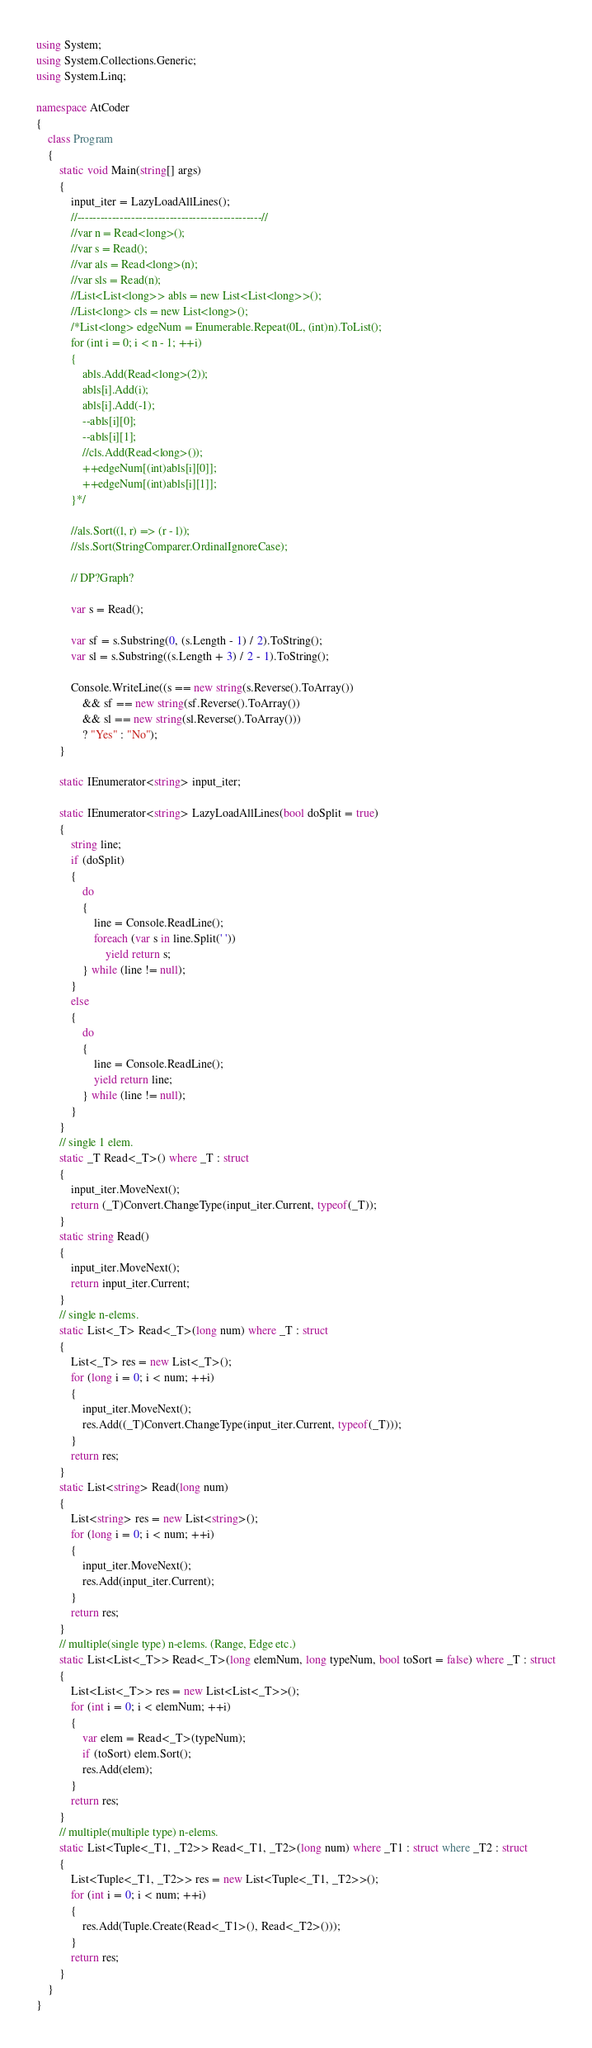Convert code to text. <code><loc_0><loc_0><loc_500><loc_500><_C#_>using System;
using System.Collections.Generic;
using System.Linq;

namespace AtCoder
{
    class Program
    {
        static void Main(string[] args)
        {
            input_iter = LazyLoadAllLines();
            //------------------------------------------------//
            //var n = Read<long>();
            //var s = Read();
            //var als = Read<long>(n);
            //var sls = Read(n);
            //List<List<long>> abls = new List<List<long>>();
            //List<long> cls = new List<long>();
            /*List<long> edgeNum = Enumerable.Repeat(0L, (int)n).ToList();
            for (int i = 0; i < n - 1; ++i)
            {
                abls.Add(Read<long>(2));
                abls[i].Add(i);
                abls[i].Add(-1);
                --abls[i][0];
                --abls[i][1];
                //cls.Add(Read<long>());
                ++edgeNum[(int)abls[i][0]];
                ++edgeNum[(int)abls[i][1]];
            }*/

            //als.Sort((l, r) => (r - l));
            //sls.Sort(StringComparer.OrdinalIgnoreCase);

            // DP?Graph?

            var s = Read();

            var sf = s.Substring(0, (s.Length - 1) / 2).ToString();
            var sl = s.Substring((s.Length + 3) / 2 - 1).ToString();

            Console.WriteLine((s == new string(s.Reverse().ToArray())
                && sf == new string(sf.Reverse().ToArray())
                && sl == new string(sl.Reverse().ToArray()))
                ? "Yes" : "No");
        }

        static IEnumerator<string> input_iter;

        static IEnumerator<string> LazyLoadAllLines(bool doSplit = true)
        {
            string line;
            if (doSplit)
            {
                do
                {
                    line = Console.ReadLine();
                    foreach (var s in line.Split(' '))
                        yield return s;
                } while (line != null);
            }
            else
            {
                do
                {
                    line = Console.ReadLine();
                    yield return line;
                } while (line != null);
            }
        }
        // single 1 elem.
        static _T Read<_T>() where _T : struct
        {
            input_iter.MoveNext();
            return (_T)Convert.ChangeType(input_iter.Current, typeof(_T));
        }
        static string Read()
        {
            input_iter.MoveNext();
            return input_iter.Current;
        }
        // single n-elems.
        static List<_T> Read<_T>(long num) where _T : struct
        {
            List<_T> res = new List<_T>();
            for (long i = 0; i < num; ++i)
            {
                input_iter.MoveNext();
                res.Add((_T)Convert.ChangeType(input_iter.Current, typeof(_T)));
            }
            return res;
        }
        static List<string> Read(long num)
        {
            List<string> res = new List<string>();
            for (long i = 0; i < num; ++i)
            {
                input_iter.MoveNext();
                res.Add(input_iter.Current);
            }
            return res;
        }
        // multiple(single type) n-elems. (Range, Edge etc.)
        static List<List<_T>> Read<_T>(long elemNum, long typeNum, bool toSort = false) where _T : struct
        {
            List<List<_T>> res = new List<List<_T>>();
            for (int i = 0; i < elemNum; ++i)
            {
                var elem = Read<_T>(typeNum);
                if (toSort) elem.Sort();
                res.Add(elem);
            }
            return res;
        }
        // multiple(multiple type) n-elems.
        static List<Tuple<_T1, _T2>> Read<_T1, _T2>(long num) where _T1 : struct where _T2 : struct
        {
            List<Tuple<_T1, _T2>> res = new List<Tuple<_T1, _T2>>();
            for (int i = 0; i < num; ++i)
            {
                res.Add(Tuple.Create(Read<_T1>(), Read<_T2>()));
            }
            return res;
        }
    }
}
</code> 